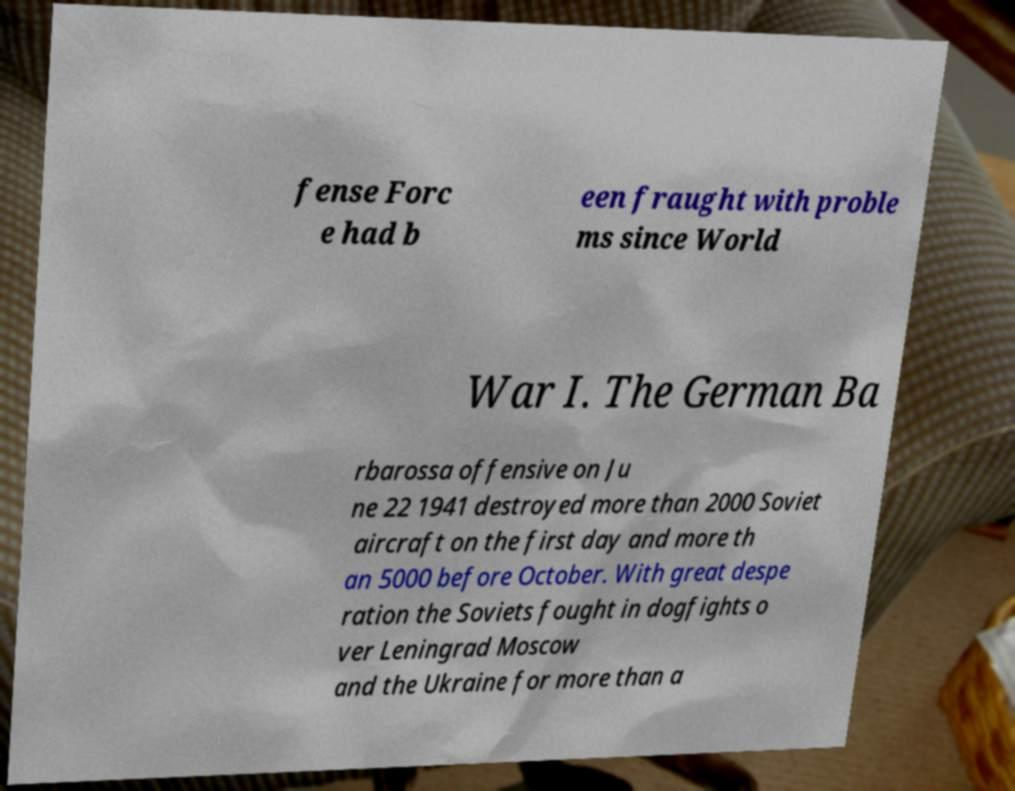I need the written content from this picture converted into text. Can you do that? fense Forc e had b een fraught with proble ms since World War I. The German Ba rbarossa offensive on Ju ne 22 1941 destroyed more than 2000 Soviet aircraft on the first day and more th an 5000 before October. With great despe ration the Soviets fought in dogfights o ver Leningrad Moscow and the Ukraine for more than a 